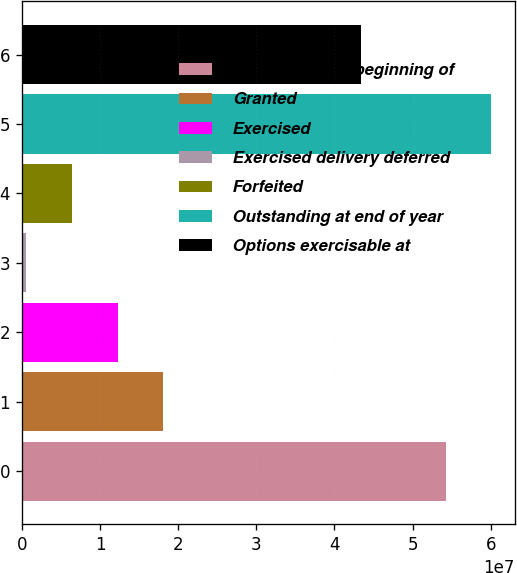Convert chart to OTSL. <chart><loc_0><loc_0><loc_500><loc_500><bar_chart><fcel>Outstanding at beginning of<fcel>Granted<fcel>Exercised<fcel>Exercised delivery deferred<fcel>Forfeited<fcel>Outstanding at end of year<fcel>Options exercisable at<nl><fcel>5.4214e+07<fcel>1.8123e+07<fcel>1.22473e+07<fcel>495787<fcel>6.37152e+06<fcel>6.00898e+07<fcel>4.33976e+07<nl></chart> 